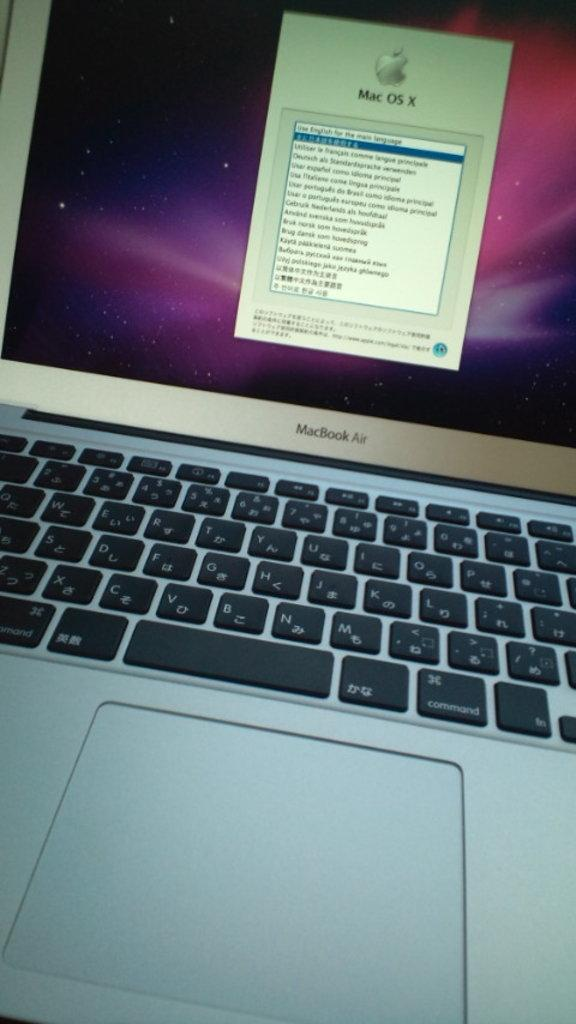What electronic device is present in the image? There is a laptop in the image. What is displayed on the laptop screen? Something is visible on the laptop screen. How many ladybugs can be seen crawling on the bushes in the image? There are no ladybugs or bushes present in the image; it only features a laptop. 